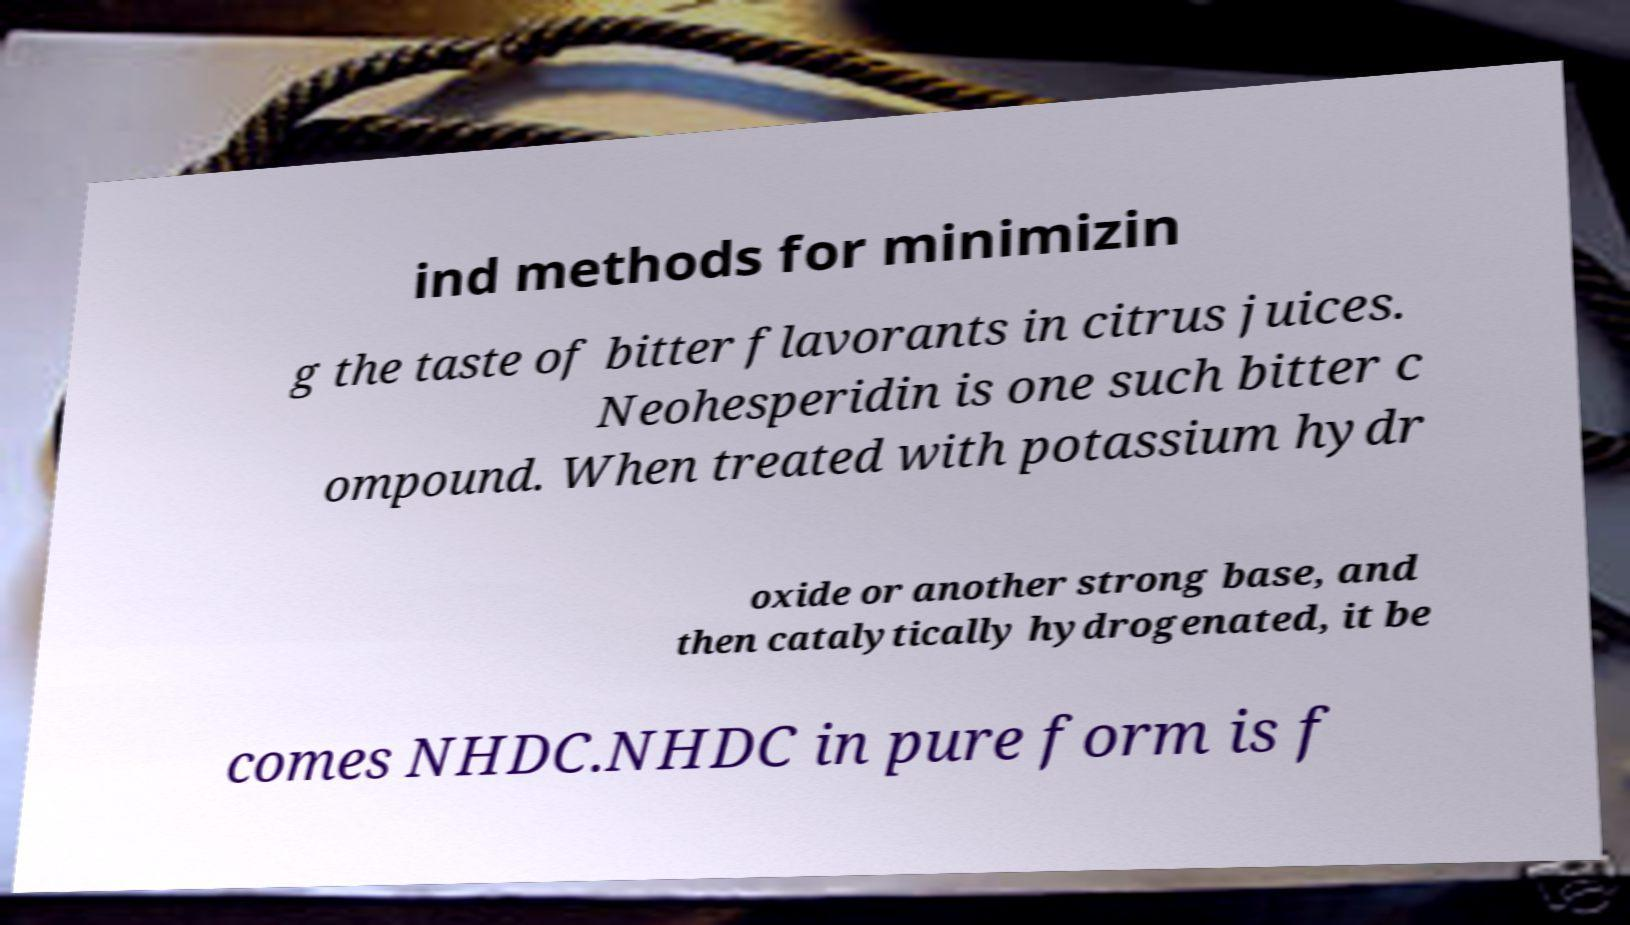Please read and relay the text visible in this image. What does it say? ind methods for minimizin g the taste of bitter flavorants in citrus juices. Neohesperidin is one such bitter c ompound. When treated with potassium hydr oxide or another strong base, and then catalytically hydrogenated, it be comes NHDC.NHDC in pure form is f 